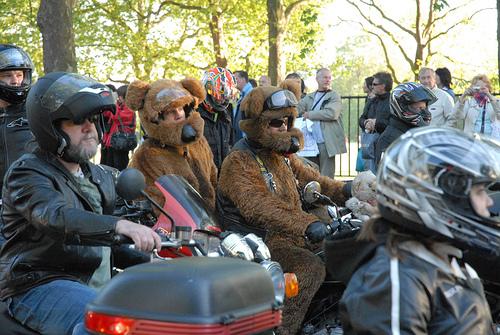How many people are in the picture?
Short answer required. 15. What type of vehicle are the people driving?
Write a very short answer. Motorcycles. What are the people in brown dressed as?
Concise answer only. Bears. 